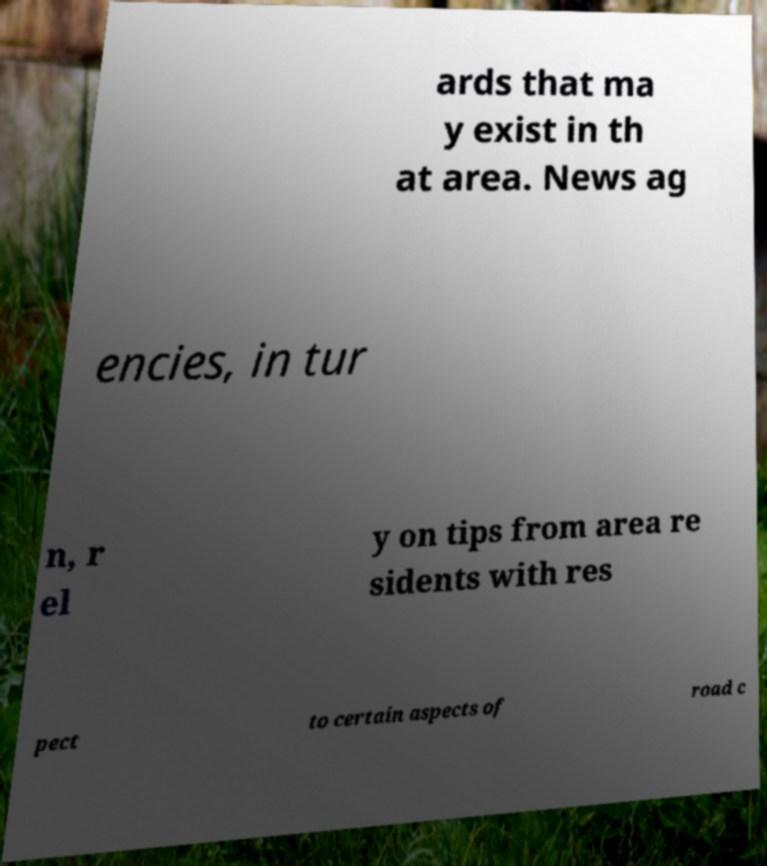Can you read and provide the text displayed in the image?This photo seems to have some interesting text. Can you extract and type it out for me? ards that ma y exist in th at area. News ag encies, in tur n, r el y on tips from area re sidents with res pect to certain aspects of road c 